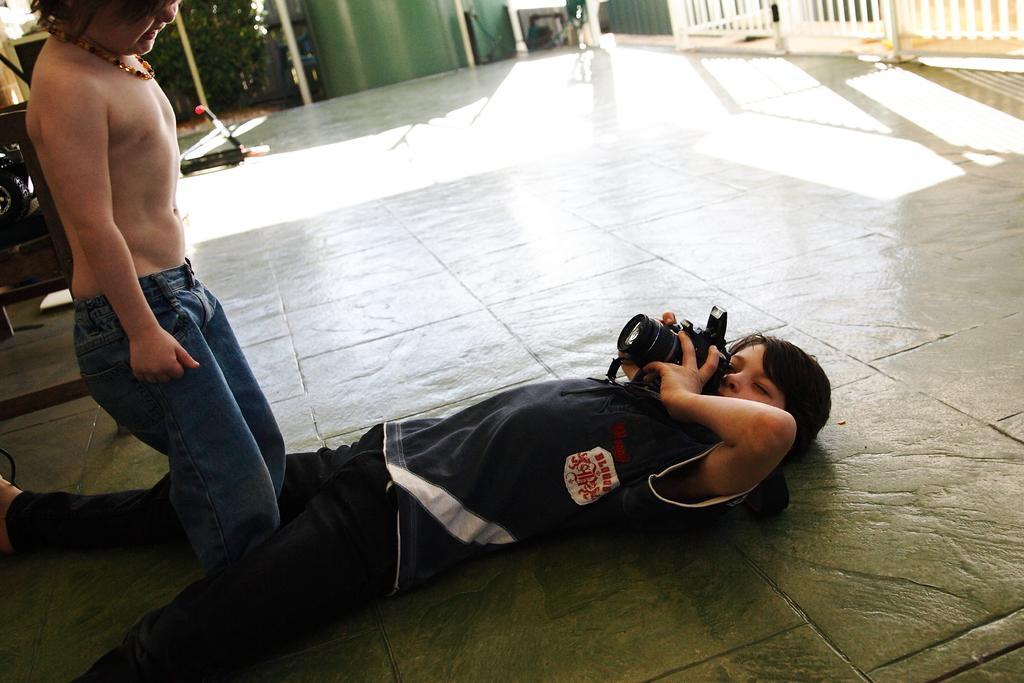How would you summarize this image in a sentence or two? In this image I can see two persons where one is lying on the ground and holding a camera and one is standing on the left side. In the background I can see few black colour things, railing and a tree. 